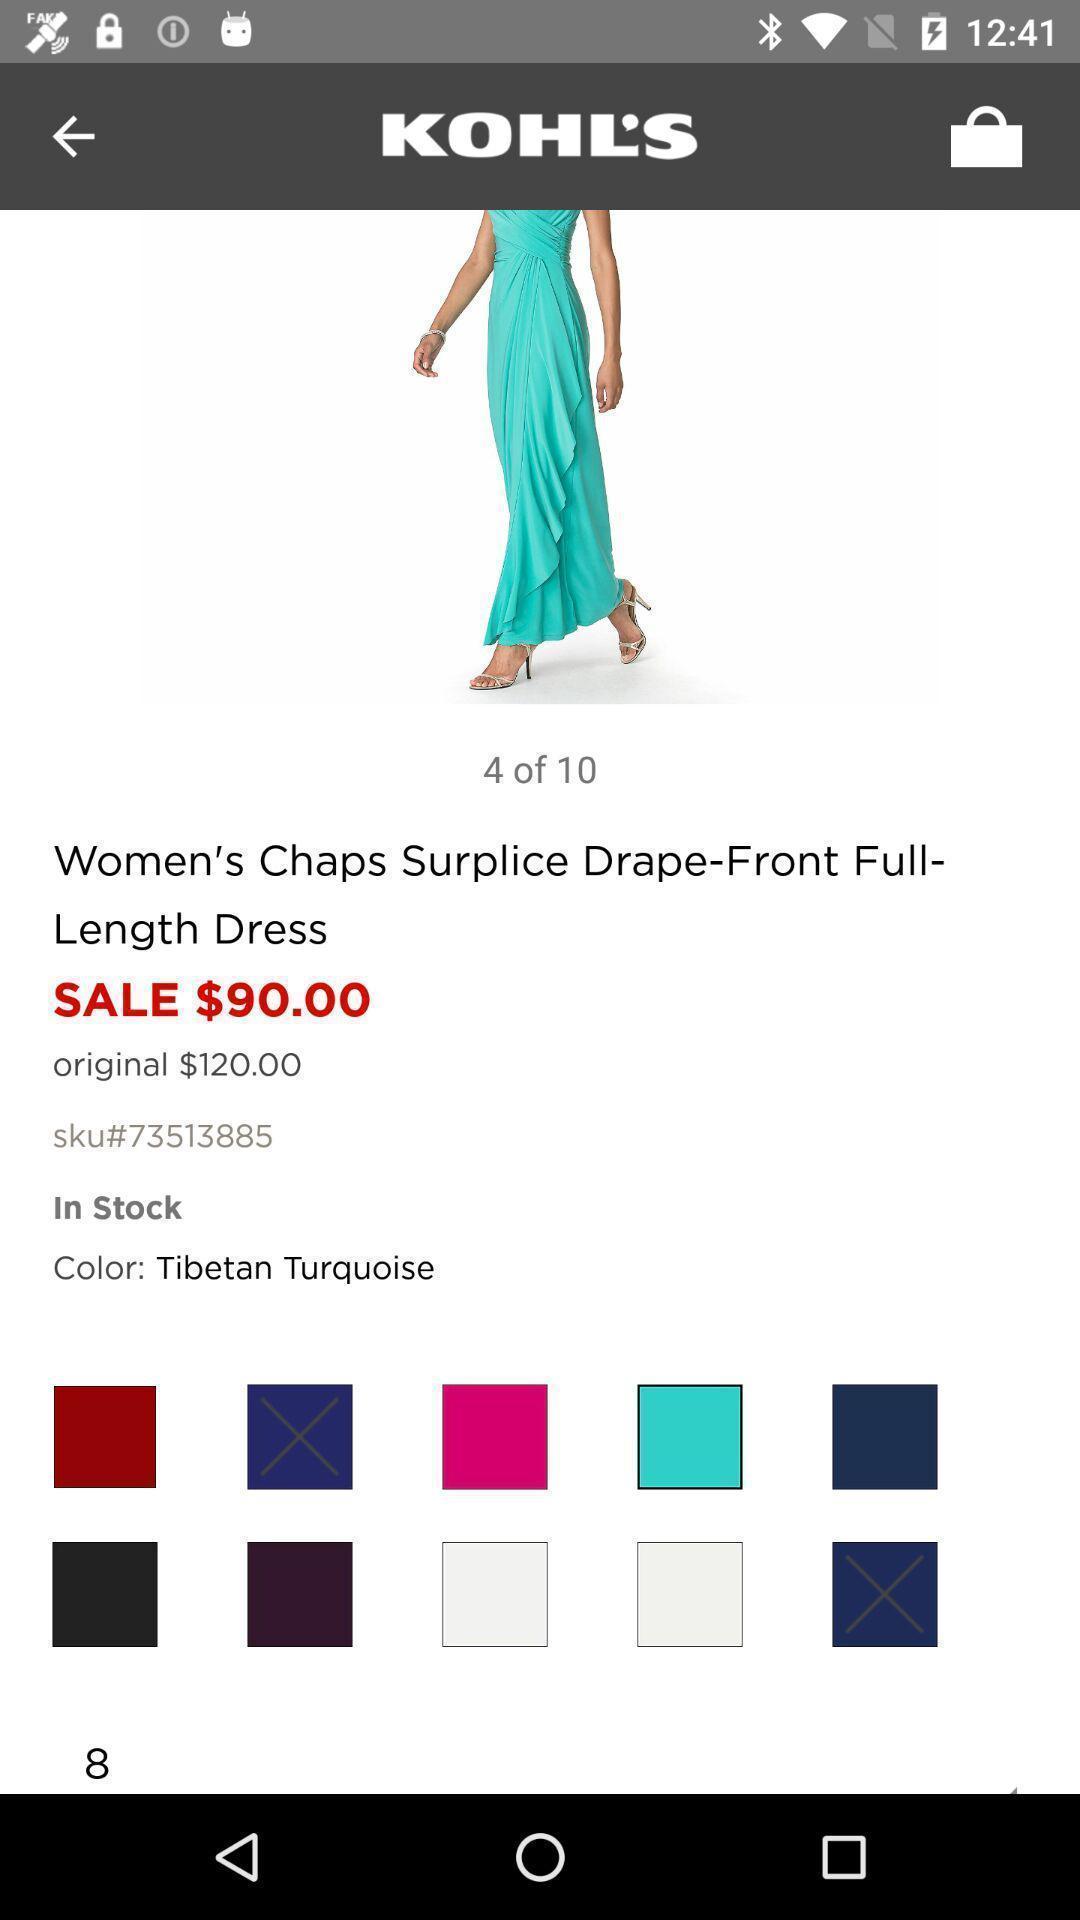Provide a detailed account of this screenshot. Page with product details in shopping app. 